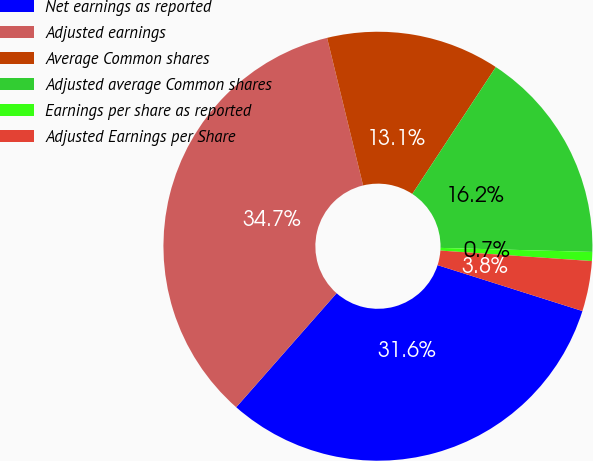Convert chart. <chart><loc_0><loc_0><loc_500><loc_500><pie_chart><fcel>Net earnings as reported<fcel>Adjusted earnings<fcel>Average Common shares<fcel>Adjusted average Common shares<fcel>Earnings per share as reported<fcel>Adjusted Earnings per Share<nl><fcel>31.6%<fcel>34.7%<fcel>13.07%<fcel>16.16%<fcel>0.68%<fcel>3.78%<nl></chart> 